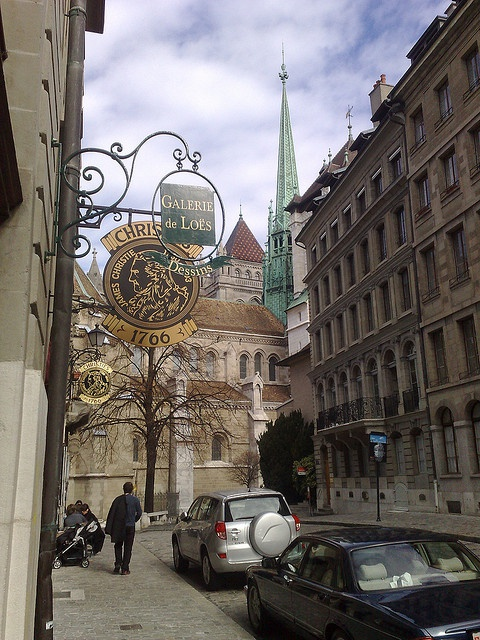Describe the objects in this image and their specific colors. I can see car in gray, black, and darkgray tones, car in gray, black, darkgray, and lightgray tones, people in gray, black, and darkgray tones, people in gray, black, and darkgray tones, and people in gray and black tones in this image. 